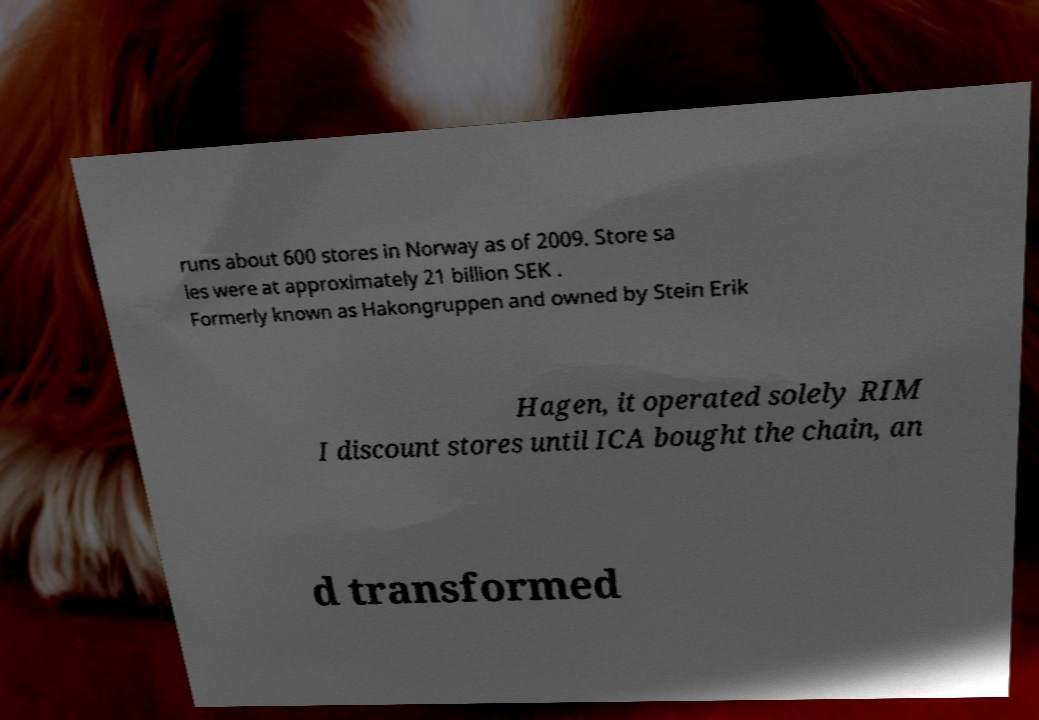Could you assist in decoding the text presented in this image and type it out clearly? runs about 600 stores in Norway as of 2009. Store sa les were at approximately 21 billion SEK . Formerly known as Hakongruppen and owned by Stein Erik Hagen, it operated solely RIM I discount stores until ICA bought the chain, an d transformed 